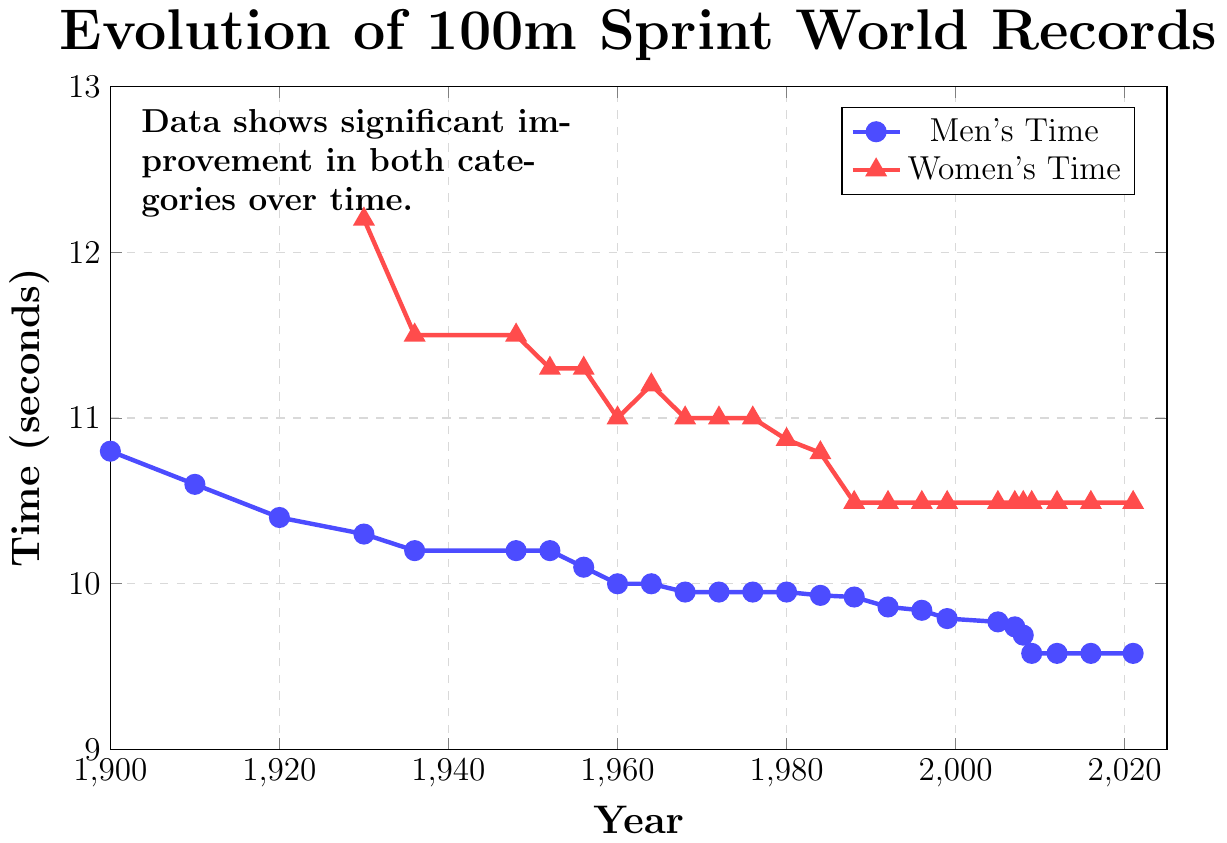What year did the men's world record first go below 10 seconds? The men's world records are plotted in blue, and by observing the blue line, we see that the first time it goes below 10 seconds is in the year 1968.
Answer: 1968 What is the difference in men's 100m sprint world record times between 1900 and 2021? In 1900, the men's world record was 10.8 seconds, and in 2021, it was 9.58 seconds. The difference is calculated by subtracting 9.58 from 10.8.
Answer: 1.22 seconds When was there a significant improvement in the women's 100m sprint world record time? By looking at the red line representing women's times, we see a significant drop between 1984 (10.79 seconds) and 1988 (10.49 seconds), indicating the major improvement.
Answer: 1988 Compare the men's and women's world record times in 1960. Which gender had a lower record and by how much? In 1960, men's world record was 10.0 seconds, and women's world record was 11.0 seconds. The men's record was lower. The difference is calculated as 11.0 - 10.0.
Answer: Men's, 1.0 seconds From 2009 to 2021, what was the men's world record time and did it change? Observing the blue line between 2009 to 2021, the men's world record time remains at 9.58 seconds and does not change.
Answer: 9.58 seconds, no change What is the average women's world record time from 1980 to 2021? The women's world record times from 1980 (10.87), 1984 (10.79), 1988 (10.49), and all subsequent years until 2021 (10.49) need to be averaged. Average: (10.87 + 10.79 + 10.49 + 10.49 + ... + 10.49)/18.
Answer: 10.51 seconds What color represents the men's 100m sprint world record line in the chart? By observing the color of the lines, we see that the men's records are marked by a blue line with circular markers.
Answer: Blue How many years did the women's world record time stay stagnant at 10.49 seconds? The women's world record time at 10.49 seconds is from 1988 to 2021. Count the years: 2021 - 1988 + 1.
Answer: 34 years Which year had world record times for both men and women recorded at exactly the same time length of 11.0 seconds? Observing both lines, we see that in the year 1960, both men's and women's world records are exactly at 11.0 seconds.
Answer: 1960 What visual attribute indicates the different genders' world records on the chart? The gender is represented by different colored and shaped markers on the lines: blue circles for men and red triangles for women.
Answer: Color and marker shape 